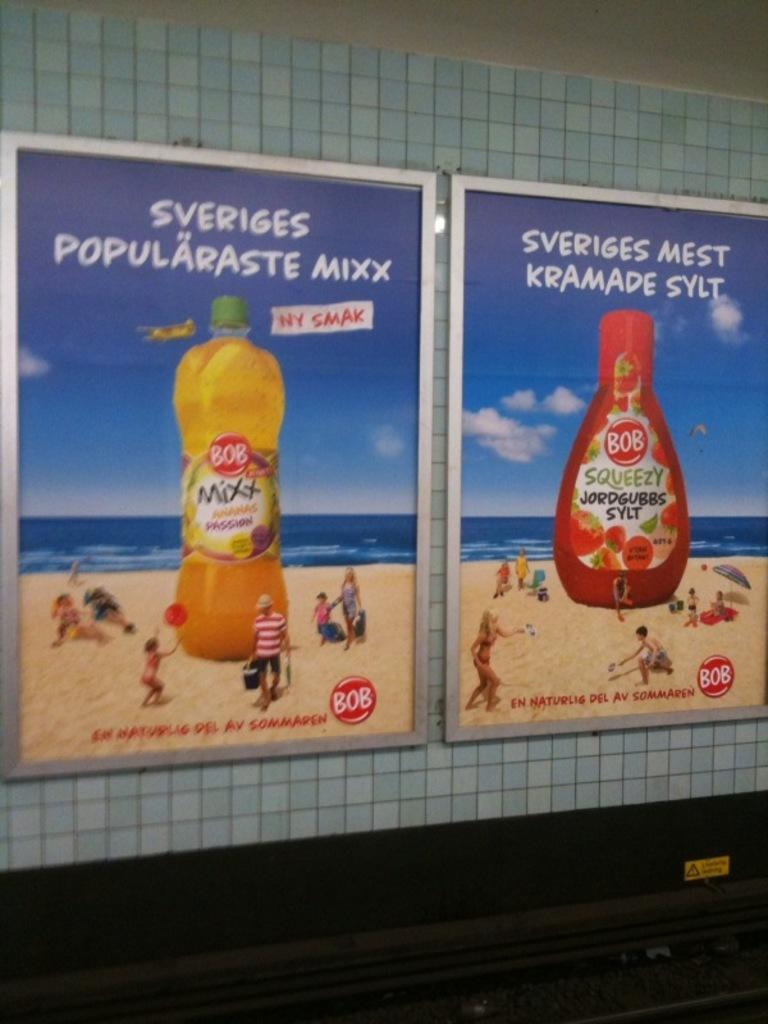<image>
Render a clear and concise summary of the photo. A tiled wall has two ads for Bob beverages that are on a beach. 